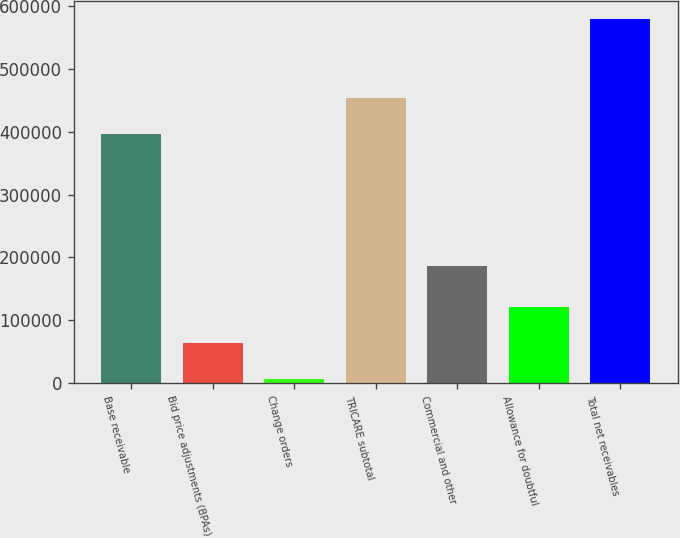<chart> <loc_0><loc_0><loc_500><loc_500><bar_chart><fcel>Base receivable<fcel>Bid price adjustments (BPAs)<fcel>Change orders<fcel>TRICARE subtotal<fcel>Commercial and other<fcel>Allowance for doubtful<fcel>Total net receivables<nl><fcel>396355<fcel>63380.4<fcel>6021<fcel>453714<fcel>186144<fcel>120740<fcel>579615<nl></chart> 